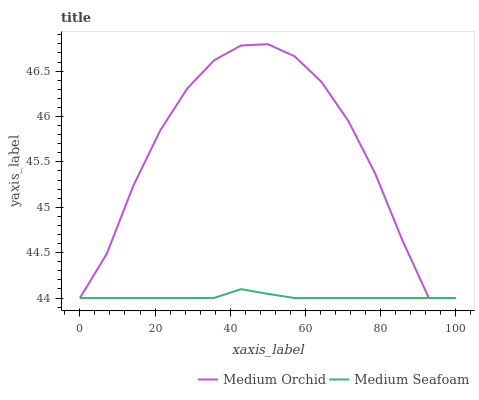Does Medium Seafoam have the minimum area under the curve?
Answer yes or no. Yes. Does Medium Orchid have the maximum area under the curve?
Answer yes or no. Yes. Does Medium Seafoam have the maximum area under the curve?
Answer yes or no. No. Is Medium Seafoam the smoothest?
Answer yes or no. Yes. Is Medium Orchid the roughest?
Answer yes or no. Yes. Is Medium Seafoam the roughest?
Answer yes or no. No. Does Medium Orchid have the lowest value?
Answer yes or no. Yes. Does Medium Orchid have the highest value?
Answer yes or no. Yes. Does Medium Seafoam have the highest value?
Answer yes or no. No. Does Medium Seafoam intersect Medium Orchid?
Answer yes or no. Yes. Is Medium Seafoam less than Medium Orchid?
Answer yes or no. No. Is Medium Seafoam greater than Medium Orchid?
Answer yes or no. No. 